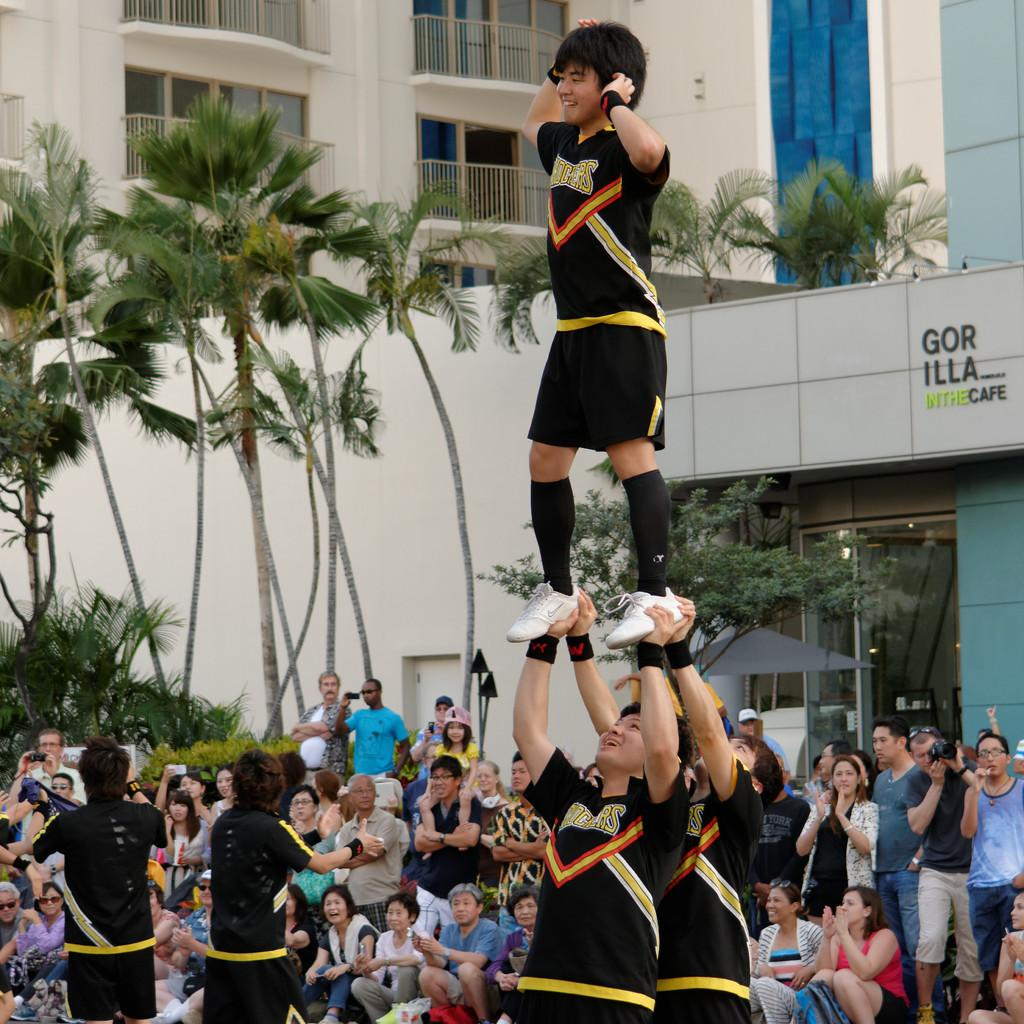<image>
Create a compact narrative representing the image presented. A pyramid of male Shockers cheerleaders performing in front of a crowd. 